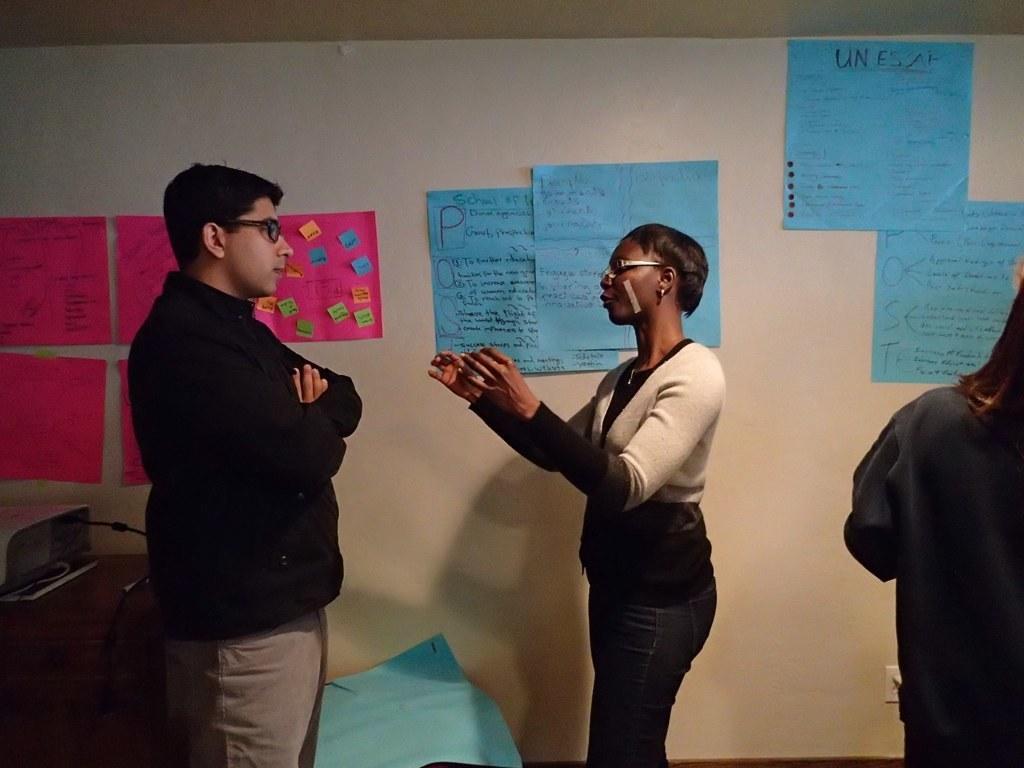In one or two sentences, can you explain what this image depicts? In this picture we can see a few people wearing spectacle and standing. We can see a person on the right side. There is a device, wire and other things on the left side. We can see a blue object at the bottom of the picture. There are a few colorful charts and a switchboard is visible on a white surface. 